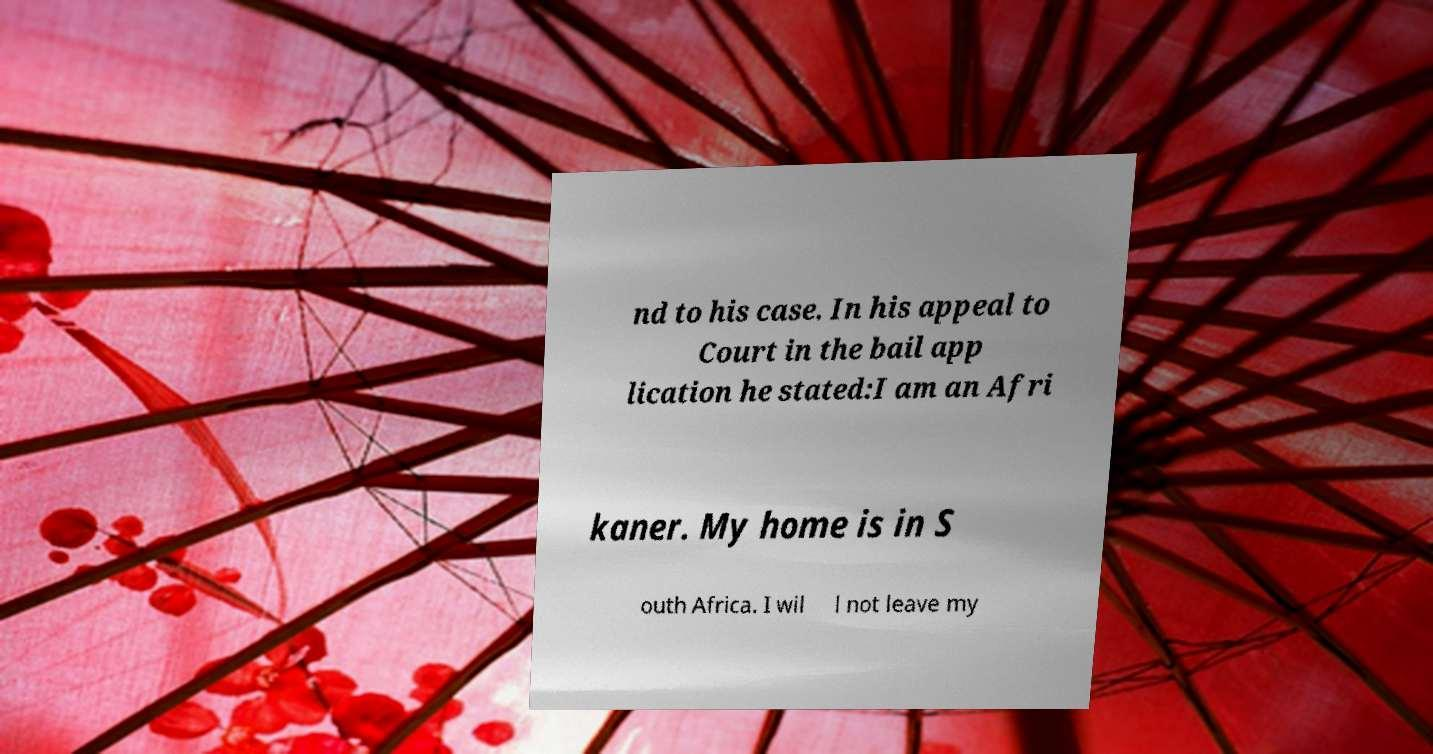Can you accurately transcribe the text from the provided image for me? nd to his case. In his appeal to Court in the bail app lication he stated:I am an Afri kaner. My home is in S outh Africa. I wil l not leave my 